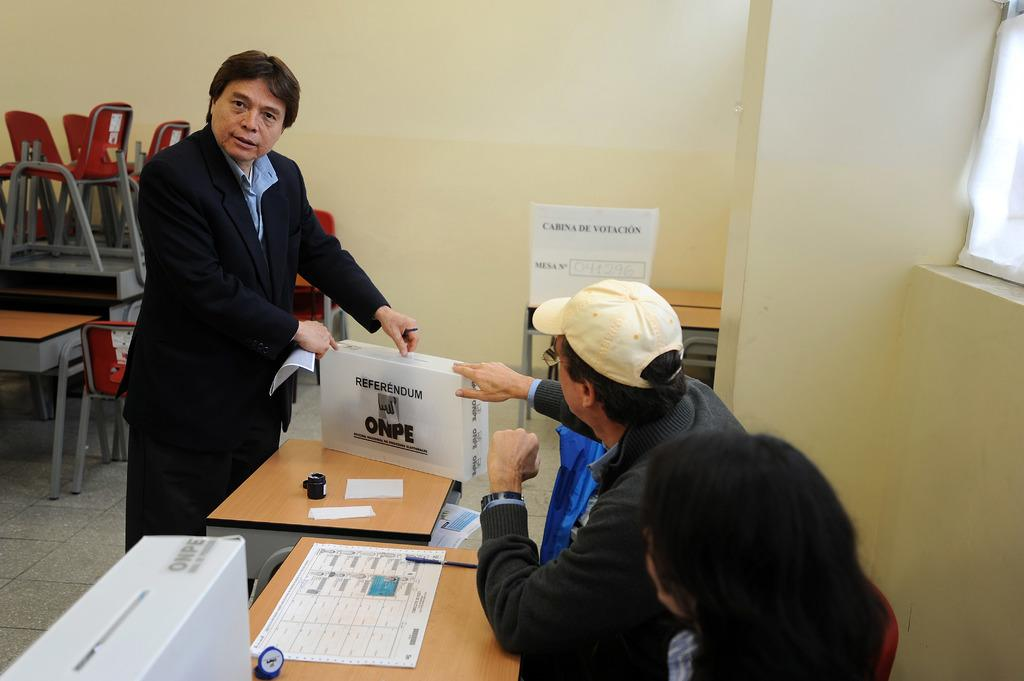How many people are present in the image? There are three people in the image. What are the seated persons doing? The seated persons are sitting in front of a table. What is the standing person doing? The standing person is holding an object in front of the seated persons. Can you see any ants crawling on the table in the image? There is no mention of ants in the provided facts, so we cannot determine if any are present in the image. What type of support is the standing person using to hold the object? The provided facts do not mention any specific support being used by the standing person to hold the object. Is there a star visible in the image? There is no mention of a star in the provided facts, so we cannot determine if one is present in the image. 